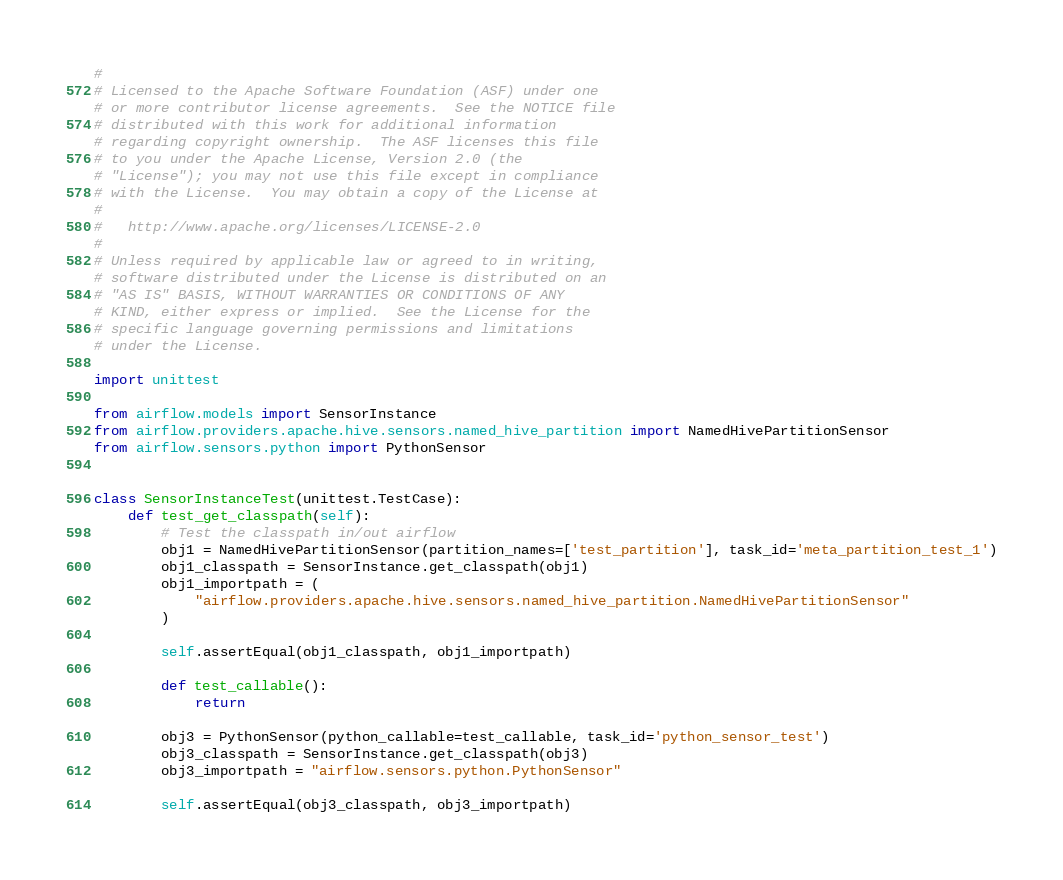<code> <loc_0><loc_0><loc_500><loc_500><_Python_>#
# Licensed to the Apache Software Foundation (ASF) under one
# or more contributor license agreements.  See the NOTICE file
# distributed with this work for additional information
# regarding copyright ownership.  The ASF licenses this file
# to you under the Apache License, Version 2.0 (the
# "License"); you may not use this file except in compliance
# with the License.  You may obtain a copy of the License at
#
#   http://www.apache.org/licenses/LICENSE-2.0
#
# Unless required by applicable law or agreed to in writing,
# software distributed under the License is distributed on an
# "AS IS" BASIS, WITHOUT WARRANTIES OR CONDITIONS OF ANY
# KIND, either express or implied.  See the License for the
# specific language governing permissions and limitations
# under the License.

import unittest

from airflow.models import SensorInstance
from airflow.providers.apache.hive.sensors.named_hive_partition import NamedHivePartitionSensor
from airflow.sensors.python import PythonSensor


class SensorInstanceTest(unittest.TestCase):
    def test_get_classpath(self):
        # Test the classpath in/out airflow
        obj1 = NamedHivePartitionSensor(partition_names=['test_partition'], task_id='meta_partition_test_1')
        obj1_classpath = SensorInstance.get_classpath(obj1)
        obj1_importpath = (
            "airflow.providers.apache.hive.sensors.named_hive_partition.NamedHivePartitionSensor"
        )

        self.assertEqual(obj1_classpath, obj1_importpath)

        def test_callable():
            return

        obj3 = PythonSensor(python_callable=test_callable, task_id='python_sensor_test')
        obj3_classpath = SensorInstance.get_classpath(obj3)
        obj3_importpath = "airflow.sensors.python.PythonSensor"

        self.assertEqual(obj3_classpath, obj3_importpath)
</code> 